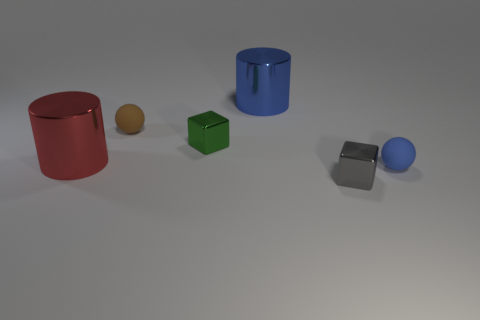Is the number of gray things greater than the number of balls?
Ensure brevity in your answer.  No. The metallic object that is behind the gray metallic block and in front of the green thing is what color?
Keep it short and to the point. Red. How many other objects are there of the same material as the brown sphere?
Offer a terse response. 1. Is the number of small brown objects less than the number of spheres?
Provide a short and direct response. Yes. Is the material of the brown object the same as the blue thing that is on the left side of the tiny gray shiny object?
Keep it short and to the point. No. What is the shape of the big metal object on the right side of the tiny brown matte object?
Keep it short and to the point. Cylinder. Is the number of tiny brown balls on the left side of the red shiny cylinder less than the number of metallic blocks?
Offer a very short reply. Yes. What number of brown matte spheres are the same size as the gray thing?
Provide a succinct answer. 1. What is the shape of the blue object that is left of the small shiny cube that is in front of the blue thing that is in front of the tiny brown ball?
Make the answer very short. Cylinder. There is a ball left of the tiny green metal thing; what is its color?
Your response must be concise. Brown. 